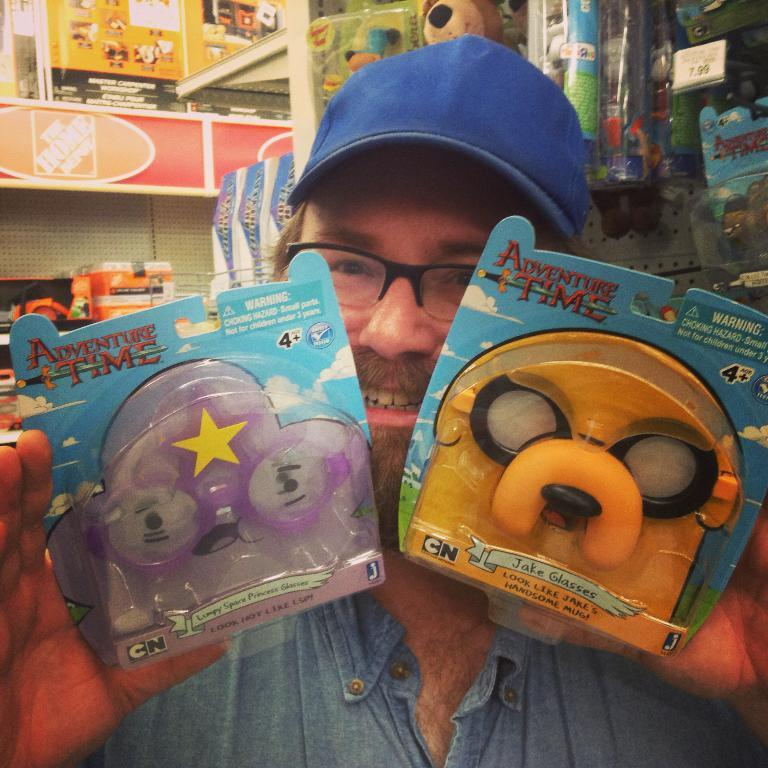What can be seen in the image? There is a person in the image. Can you describe the person's appearance? The person is wearing glasses and a cap. What is the person holding in the image? The person is holding some objects. What can be seen in the background of the image? There are toys, boards, and other objects in the background. What type of plane is visible in the image? There is no plane visible in the image; it only features a person, their appearance, and the objects they are holding, as well as the background. 